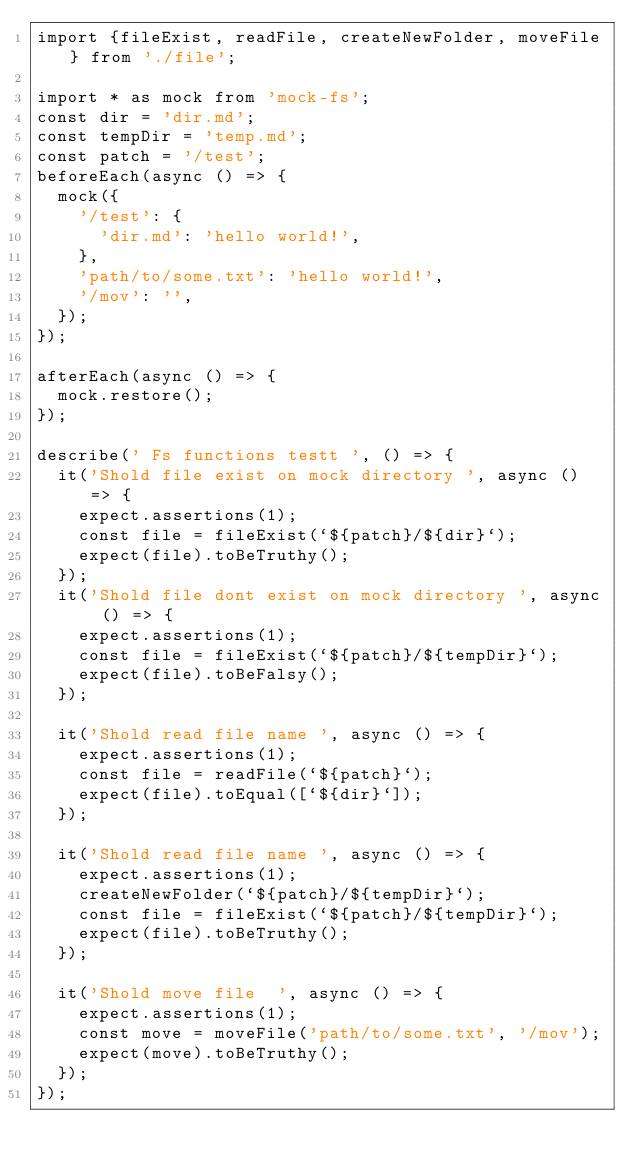Convert code to text. <code><loc_0><loc_0><loc_500><loc_500><_TypeScript_>import {fileExist, readFile, createNewFolder, moveFile} from './file';

import * as mock from 'mock-fs';
const dir = 'dir.md';
const tempDir = 'temp.md';
const patch = '/test';
beforeEach(async () => {
  mock({
    '/test': {
      'dir.md': 'hello world!',
    },
    'path/to/some.txt': 'hello world!',
    '/mov': '',
  });
});

afterEach(async () => {
  mock.restore();
});

describe(' Fs functions testt ', () => {
  it('Shold file exist on mock directory ', async () => {
    expect.assertions(1);
    const file = fileExist(`${patch}/${dir}`);
    expect(file).toBeTruthy();
  });
  it('Shold file dont exist on mock directory ', async () => {
    expect.assertions(1);
    const file = fileExist(`${patch}/${tempDir}`);
    expect(file).toBeFalsy();
  });

  it('Shold read file name ', async () => {
    expect.assertions(1);
    const file = readFile(`${patch}`);
    expect(file).toEqual([`${dir}`]);
  });

  it('Shold read file name ', async () => {
    expect.assertions(1);
    createNewFolder(`${patch}/${tempDir}`);
    const file = fileExist(`${patch}/${tempDir}`);
    expect(file).toBeTruthy();
  });

  it('Shold move file  ', async () => {
    expect.assertions(1);
    const move = moveFile('path/to/some.txt', '/mov');
    expect(move).toBeTruthy();
  });
});
</code> 